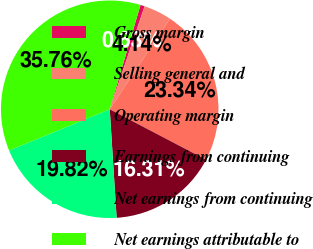Convert chart. <chart><loc_0><loc_0><loc_500><loc_500><pie_chart><fcel>Gross margin<fcel>Selling general and<fcel>Operating margin<fcel>Earnings from continuing<fcel>Net earnings from continuing<fcel>Net earnings attributable to<nl><fcel>0.63%<fcel>4.14%<fcel>23.34%<fcel>16.31%<fcel>19.82%<fcel>35.76%<nl></chart> 